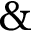Convert formula to latex. <formula><loc_0><loc_0><loc_500><loc_500>\&</formula> 